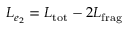<formula> <loc_0><loc_0><loc_500><loc_500>L _ { e _ { 2 } } = L _ { t o t } - 2 L _ { f r a g }</formula> 